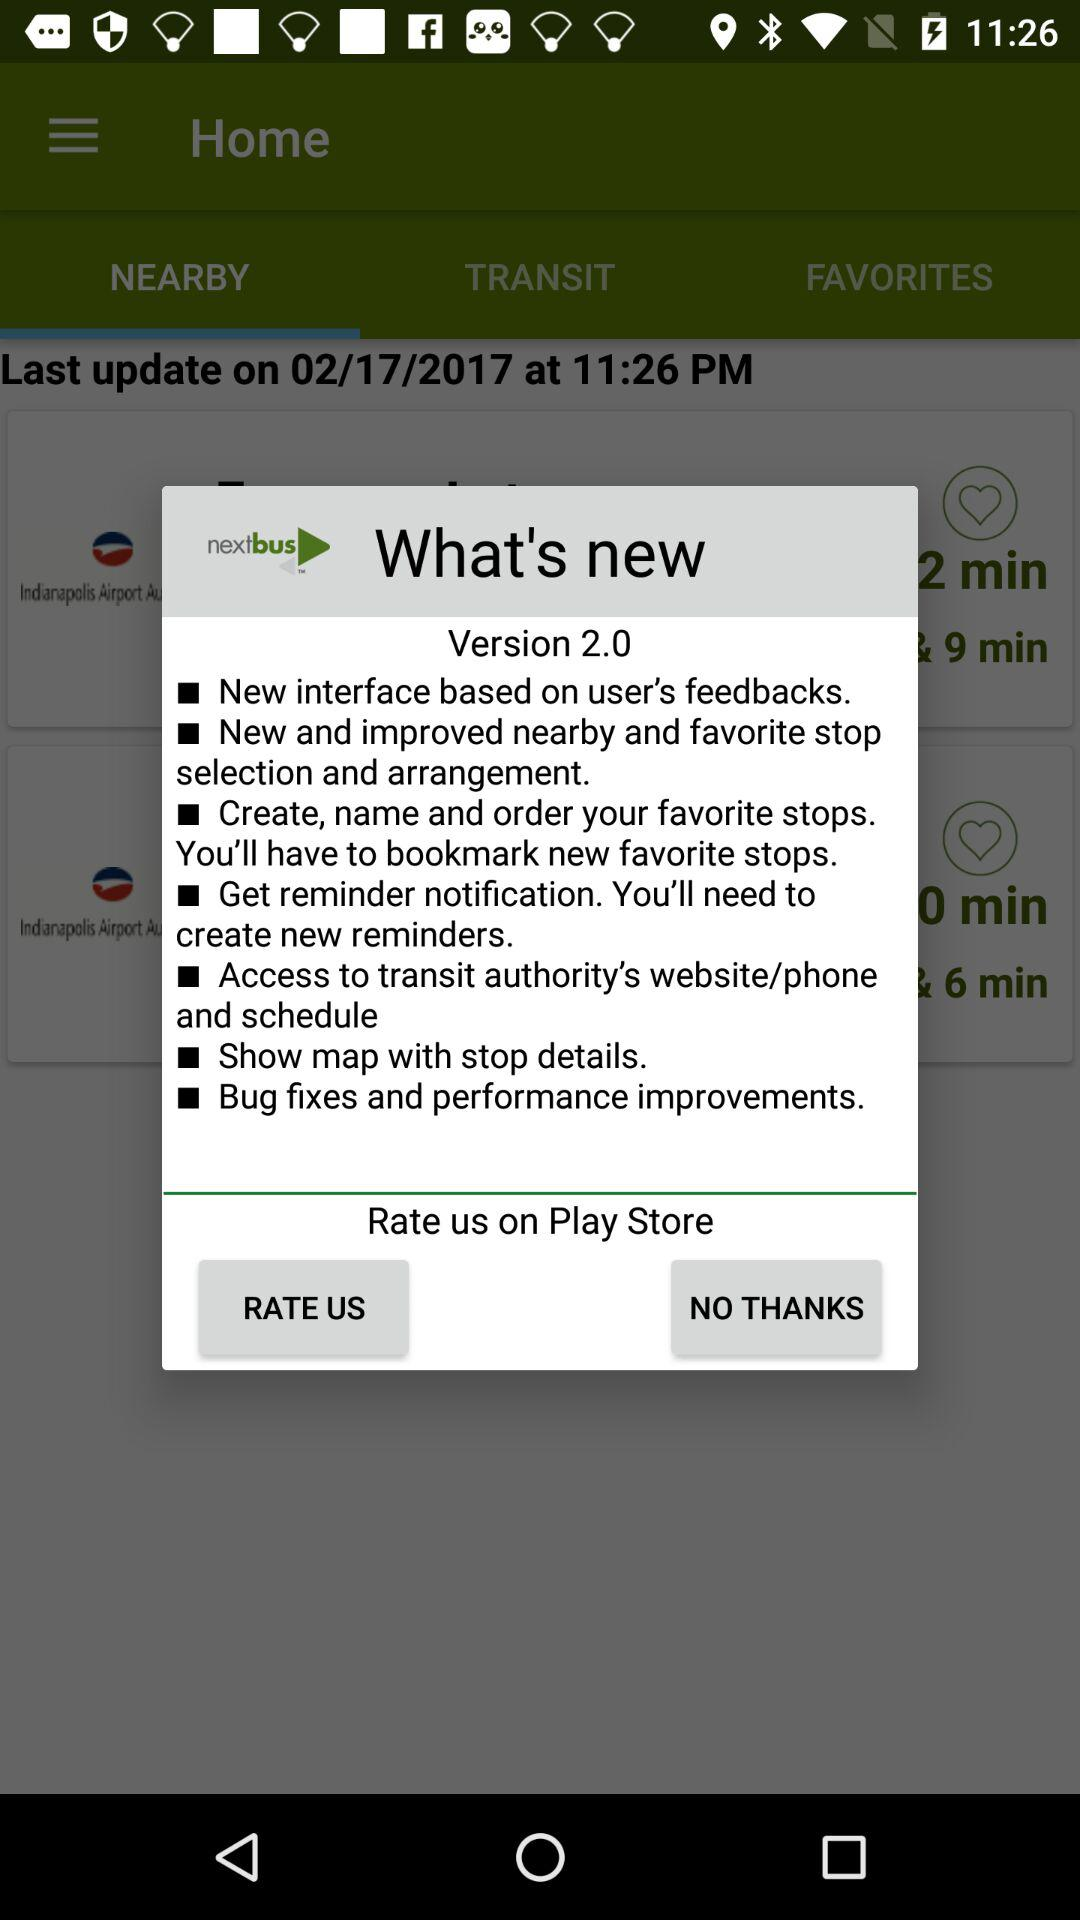Where can we rate the application? You can rate the application on "Play Store". 